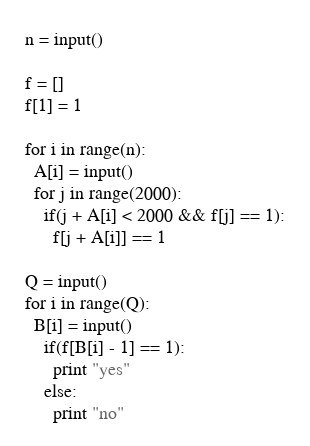Convert code to text. <code><loc_0><loc_0><loc_500><loc_500><_Python_>n = input()

f = []
f[1] = 1

for i in range(n):
  A[i] = input()
  for j in range(2000):
    if(j + A[i] < 2000 && f[j] == 1):
      f[j + A[i]] == 1
    
Q = input()
for i in range(Q):
  B[i] = input()
    if(f[B[i] - 1] == 1):
      print "yes"
    else:
      print "no"</code> 